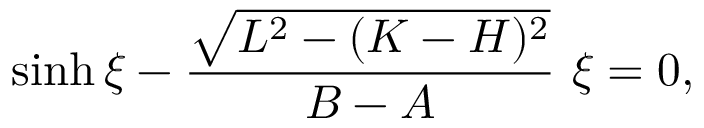<formula> <loc_0><loc_0><loc_500><loc_500>\sinh \xi - \frac { \sqrt { L ^ { 2 } - ( K - H ) ^ { 2 } } } { B - A } \xi = 0 ,</formula> 